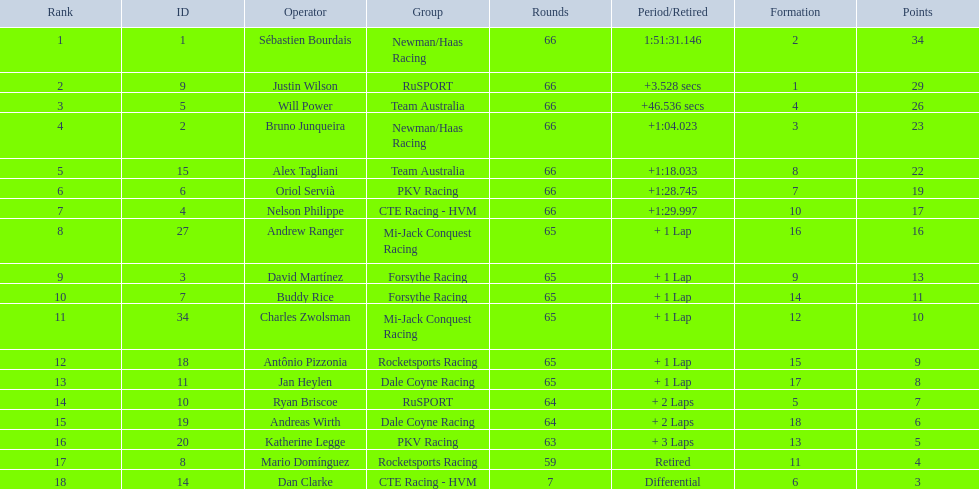Who finished directly after the driver who finished in 1:28.745? Nelson Philippe. 